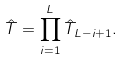<formula> <loc_0><loc_0><loc_500><loc_500>\hat { T } = \prod _ { i = 1 } ^ { L } \hat { T } _ { L - i + 1 } .</formula> 